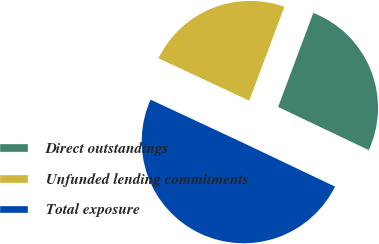Convert chart. <chart><loc_0><loc_0><loc_500><loc_500><pie_chart><fcel>Direct outstandings<fcel>Unfunded lending commitments<fcel>Total exposure<nl><fcel>26.37%<fcel>23.75%<fcel>49.88%<nl></chart> 